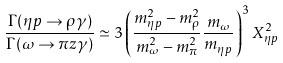Convert formula to latex. <formula><loc_0><loc_0><loc_500><loc_500>\frac { \Gamma ( \eta p \rightarrow \rho \gamma ) } { \Gamma ( \omega \rightarrow \pi z \gamma ) } \simeq 3 \left ( \frac { m ^ { 2 } _ { \eta p } - m ^ { 2 } _ { \rho } } { m ^ { 2 } _ { \omega } - m ^ { 2 } _ { \pi } } \frac { m _ { \omega } } { m _ { \eta p } } \right ) ^ { 3 } X _ { \eta p } ^ { 2 }</formula> 